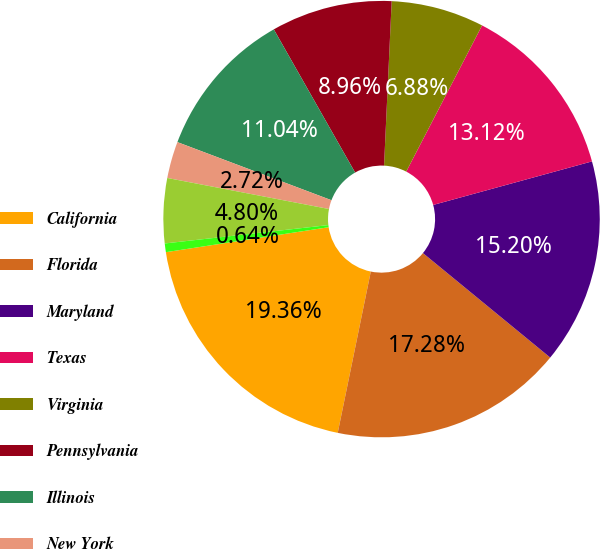Convert chart. <chart><loc_0><loc_0><loc_500><loc_500><pie_chart><fcel>California<fcel>Florida<fcel>Maryland<fcel>Texas<fcel>Virginia<fcel>Pennsylvania<fcel>Illinois<fcel>New York<fcel>Ohio<fcel>New Jersey<nl><fcel>19.36%<fcel>17.28%<fcel>15.2%<fcel>13.12%<fcel>6.88%<fcel>8.96%<fcel>11.04%<fcel>2.72%<fcel>4.8%<fcel>0.64%<nl></chart> 